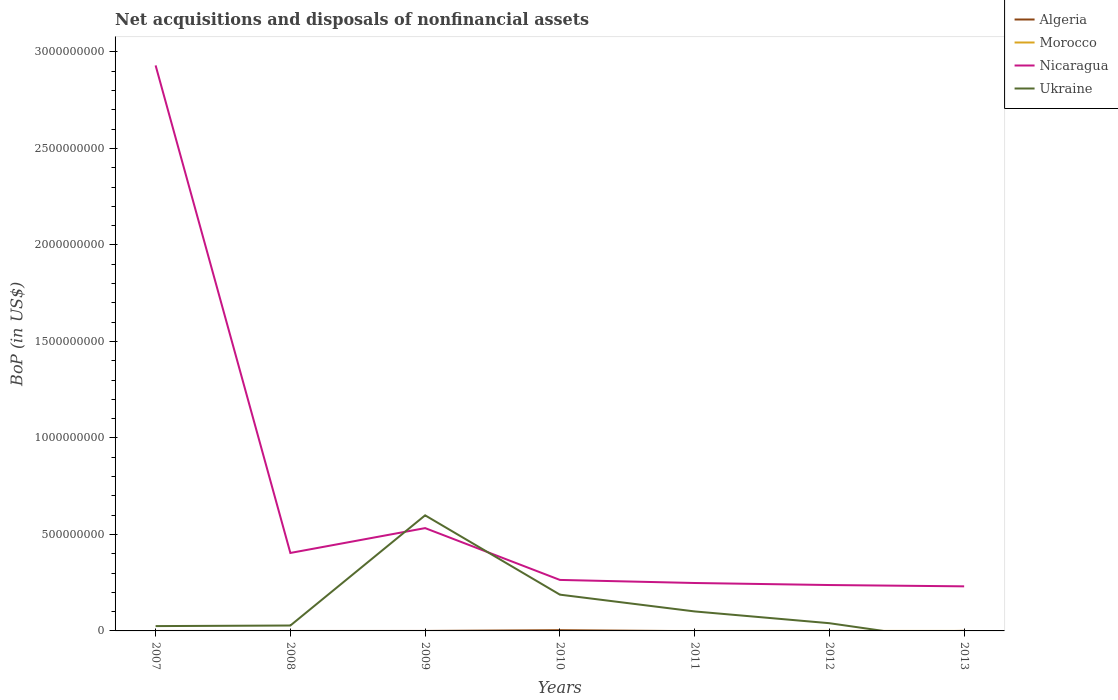Does the line corresponding to Nicaragua intersect with the line corresponding to Algeria?
Offer a very short reply. No. Is the number of lines equal to the number of legend labels?
Offer a terse response. No. What is the total Balance of Payments in Nicaragua in the graph?
Provide a succinct answer. 1.73e+07. What is the difference between the highest and the second highest Balance of Payments in Morocco?
Your response must be concise. 1.28e+05. What is the difference between the highest and the lowest Balance of Payments in Nicaragua?
Your answer should be compact. 1. Is the Balance of Payments in Algeria strictly greater than the Balance of Payments in Morocco over the years?
Your answer should be very brief. No. What is the difference between two consecutive major ticks on the Y-axis?
Your answer should be very brief. 5.00e+08. Does the graph contain any zero values?
Offer a terse response. Yes. Does the graph contain grids?
Your answer should be very brief. No. How are the legend labels stacked?
Your answer should be compact. Vertical. What is the title of the graph?
Provide a short and direct response. Net acquisitions and disposals of nonfinancial assets. Does "Poland" appear as one of the legend labels in the graph?
Your response must be concise. No. What is the label or title of the X-axis?
Ensure brevity in your answer.  Years. What is the label or title of the Y-axis?
Make the answer very short. BoP (in US$). What is the BoP (in US$) of Algeria in 2007?
Your response must be concise. 0. What is the BoP (in US$) in Nicaragua in 2007?
Your answer should be very brief. 2.93e+09. What is the BoP (in US$) in Ukraine in 2007?
Ensure brevity in your answer.  2.50e+07. What is the BoP (in US$) of Morocco in 2008?
Your answer should be very brief. 0. What is the BoP (in US$) in Nicaragua in 2008?
Give a very brief answer. 4.04e+08. What is the BoP (in US$) in Ukraine in 2008?
Provide a succinct answer. 2.80e+07. What is the BoP (in US$) of Algeria in 2009?
Give a very brief answer. 0. What is the BoP (in US$) of Morocco in 2009?
Provide a succinct answer. 0. What is the BoP (in US$) in Nicaragua in 2009?
Make the answer very short. 5.33e+08. What is the BoP (in US$) in Ukraine in 2009?
Offer a very short reply. 5.99e+08. What is the BoP (in US$) in Algeria in 2010?
Ensure brevity in your answer.  3.82e+06. What is the BoP (in US$) of Morocco in 2010?
Ensure brevity in your answer.  0. What is the BoP (in US$) in Nicaragua in 2010?
Your answer should be very brief. 2.64e+08. What is the BoP (in US$) in Ukraine in 2010?
Your answer should be compact. 1.88e+08. What is the BoP (in US$) of Algeria in 2011?
Offer a terse response. 0. What is the BoP (in US$) of Nicaragua in 2011?
Offer a very short reply. 2.48e+08. What is the BoP (in US$) in Ukraine in 2011?
Make the answer very short. 1.01e+08. What is the BoP (in US$) of Algeria in 2012?
Offer a terse response. 0. What is the BoP (in US$) of Morocco in 2012?
Provide a short and direct response. 1.28e+05. What is the BoP (in US$) in Nicaragua in 2012?
Your response must be concise. 2.38e+08. What is the BoP (in US$) of Ukraine in 2012?
Give a very brief answer. 4.00e+07. What is the BoP (in US$) of Algeria in 2013?
Make the answer very short. 2.24e+05. What is the BoP (in US$) of Morocco in 2013?
Offer a terse response. 0. What is the BoP (in US$) of Nicaragua in 2013?
Your answer should be compact. 2.31e+08. What is the BoP (in US$) in Ukraine in 2013?
Provide a succinct answer. 0. Across all years, what is the maximum BoP (in US$) of Algeria?
Your answer should be compact. 3.82e+06. Across all years, what is the maximum BoP (in US$) in Morocco?
Ensure brevity in your answer.  1.28e+05. Across all years, what is the maximum BoP (in US$) in Nicaragua?
Your response must be concise. 2.93e+09. Across all years, what is the maximum BoP (in US$) of Ukraine?
Provide a short and direct response. 5.99e+08. Across all years, what is the minimum BoP (in US$) in Algeria?
Offer a very short reply. 0. Across all years, what is the minimum BoP (in US$) of Nicaragua?
Make the answer very short. 2.31e+08. Across all years, what is the minimum BoP (in US$) in Ukraine?
Provide a short and direct response. 0. What is the total BoP (in US$) of Algeria in the graph?
Provide a short and direct response. 4.05e+06. What is the total BoP (in US$) in Morocco in the graph?
Keep it short and to the point. 1.28e+05. What is the total BoP (in US$) in Nicaragua in the graph?
Your answer should be compact. 4.85e+09. What is the total BoP (in US$) of Ukraine in the graph?
Provide a short and direct response. 9.81e+08. What is the difference between the BoP (in US$) of Nicaragua in 2007 and that in 2008?
Provide a short and direct response. 2.53e+09. What is the difference between the BoP (in US$) in Ukraine in 2007 and that in 2008?
Your answer should be compact. -3.00e+06. What is the difference between the BoP (in US$) in Nicaragua in 2007 and that in 2009?
Offer a terse response. 2.40e+09. What is the difference between the BoP (in US$) in Ukraine in 2007 and that in 2009?
Ensure brevity in your answer.  -5.74e+08. What is the difference between the BoP (in US$) of Nicaragua in 2007 and that in 2010?
Provide a succinct answer. 2.67e+09. What is the difference between the BoP (in US$) of Ukraine in 2007 and that in 2010?
Make the answer very short. -1.63e+08. What is the difference between the BoP (in US$) of Nicaragua in 2007 and that in 2011?
Give a very brief answer. 2.68e+09. What is the difference between the BoP (in US$) of Ukraine in 2007 and that in 2011?
Your answer should be compact. -7.60e+07. What is the difference between the BoP (in US$) in Nicaragua in 2007 and that in 2012?
Your answer should be very brief. 2.69e+09. What is the difference between the BoP (in US$) of Ukraine in 2007 and that in 2012?
Offer a terse response. -1.50e+07. What is the difference between the BoP (in US$) in Nicaragua in 2007 and that in 2013?
Make the answer very short. 2.70e+09. What is the difference between the BoP (in US$) of Nicaragua in 2008 and that in 2009?
Your answer should be very brief. -1.29e+08. What is the difference between the BoP (in US$) of Ukraine in 2008 and that in 2009?
Offer a very short reply. -5.71e+08. What is the difference between the BoP (in US$) of Nicaragua in 2008 and that in 2010?
Make the answer very short. 1.40e+08. What is the difference between the BoP (in US$) in Ukraine in 2008 and that in 2010?
Provide a short and direct response. -1.60e+08. What is the difference between the BoP (in US$) of Nicaragua in 2008 and that in 2011?
Your answer should be very brief. 1.56e+08. What is the difference between the BoP (in US$) of Ukraine in 2008 and that in 2011?
Your response must be concise. -7.30e+07. What is the difference between the BoP (in US$) of Nicaragua in 2008 and that in 2012?
Ensure brevity in your answer.  1.66e+08. What is the difference between the BoP (in US$) in Ukraine in 2008 and that in 2012?
Ensure brevity in your answer.  -1.20e+07. What is the difference between the BoP (in US$) of Nicaragua in 2008 and that in 2013?
Offer a terse response. 1.73e+08. What is the difference between the BoP (in US$) of Nicaragua in 2009 and that in 2010?
Ensure brevity in your answer.  2.68e+08. What is the difference between the BoP (in US$) of Ukraine in 2009 and that in 2010?
Keep it short and to the point. 4.11e+08. What is the difference between the BoP (in US$) of Nicaragua in 2009 and that in 2011?
Provide a short and direct response. 2.84e+08. What is the difference between the BoP (in US$) of Ukraine in 2009 and that in 2011?
Your response must be concise. 4.98e+08. What is the difference between the BoP (in US$) in Nicaragua in 2009 and that in 2012?
Ensure brevity in your answer.  2.95e+08. What is the difference between the BoP (in US$) of Ukraine in 2009 and that in 2012?
Your answer should be very brief. 5.59e+08. What is the difference between the BoP (in US$) of Nicaragua in 2009 and that in 2013?
Offer a terse response. 3.02e+08. What is the difference between the BoP (in US$) of Nicaragua in 2010 and that in 2011?
Ensure brevity in your answer.  1.60e+07. What is the difference between the BoP (in US$) of Ukraine in 2010 and that in 2011?
Keep it short and to the point. 8.70e+07. What is the difference between the BoP (in US$) of Nicaragua in 2010 and that in 2012?
Your response must be concise. 2.65e+07. What is the difference between the BoP (in US$) in Ukraine in 2010 and that in 2012?
Your response must be concise. 1.48e+08. What is the difference between the BoP (in US$) of Algeria in 2010 and that in 2013?
Ensure brevity in your answer.  3.60e+06. What is the difference between the BoP (in US$) in Nicaragua in 2010 and that in 2013?
Your answer should be compact. 3.33e+07. What is the difference between the BoP (in US$) in Nicaragua in 2011 and that in 2012?
Give a very brief answer. 1.05e+07. What is the difference between the BoP (in US$) in Ukraine in 2011 and that in 2012?
Provide a short and direct response. 6.10e+07. What is the difference between the BoP (in US$) of Nicaragua in 2011 and that in 2013?
Your answer should be very brief. 1.73e+07. What is the difference between the BoP (in US$) in Nicaragua in 2012 and that in 2013?
Keep it short and to the point. 6.80e+06. What is the difference between the BoP (in US$) of Nicaragua in 2007 and the BoP (in US$) of Ukraine in 2008?
Your answer should be very brief. 2.90e+09. What is the difference between the BoP (in US$) in Nicaragua in 2007 and the BoP (in US$) in Ukraine in 2009?
Your answer should be very brief. 2.33e+09. What is the difference between the BoP (in US$) of Nicaragua in 2007 and the BoP (in US$) of Ukraine in 2010?
Offer a terse response. 2.74e+09. What is the difference between the BoP (in US$) of Nicaragua in 2007 and the BoP (in US$) of Ukraine in 2011?
Offer a terse response. 2.83e+09. What is the difference between the BoP (in US$) of Nicaragua in 2007 and the BoP (in US$) of Ukraine in 2012?
Provide a succinct answer. 2.89e+09. What is the difference between the BoP (in US$) in Nicaragua in 2008 and the BoP (in US$) in Ukraine in 2009?
Offer a very short reply. -1.95e+08. What is the difference between the BoP (in US$) of Nicaragua in 2008 and the BoP (in US$) of Ukraine in 2010?
Ensure brevity in your answer.  2.16e+08. What is the difference between the BoP (in US$) of Nicaragua in 2008 and the BoP (in US$) of Ukraine in 2011?
Ensure brevity in your answer.  3.03e+08. What is the difference between the BoP (in US$) of Nicaragua in 2008 and the BoP (in US$) of Ukraine in 2012?
Make the answer very short. 3.64e+08. What is the difference between the BoP (in US$) of Nicaragua in 2009 and the BoP (in US$) of Ukraine in 2010?
Your response must be concise. 3.45e+08. What is the difference between the BoP (in US$) in Nicaragua in 2009 and the BoP (in US$) in Ukraine in 2011?
Keep it short and to the point. 4.32e+08. What is the difference between the BoP (in US$) in Nicaragua in 2009 and the BoP (in US$) in Ukraine in 2012?
Give a very brief answer. 4.93e+08. What is the difference between the BoP (in US$) in Algeria in 2010 and the BoP (in US$) in Nicaragua in 2011?
Make the answer very short. -2.44e+08. What is the difference between the BoP (in US$) in Algeria in 2010 and the BoP (in US$) in Ukraine in 2011?
Offer a very short reply. -9.72e+07. What is the difference between the BoP (in US$) in Nicaragua in 2010 and the BoP (in US$) in Ukraine in 2011?
Give a very brief answer. 1.63e+08. What is the difference between the BoP (in US$) of Algeria in 2010 and the BoP (in US$) of Morocco in 2012?
Give a very brief answer. 3.70e+06. What is the difference between the BoP (in US$) in Algeria in 2010 and the BoP (in US$) in Nicaragua in 2012?
Ensure brevity in your answer.  -2.34e+08. What is the difference between the BoP (in US$) in Algeria in 2010 and the BoP (in US$) in Ukraine in 2012?
Your response must be concise. -3.62e+07. What is the difference between the BoP (in US$) in Nicaragua in 2010 and the BoP (in US$) in Ukraine in 2012?
Make the answer very short. 2.24e+08. What is the difference between the BoP (in US$) of Algeria in 2010 and the BoP (in US$) of Nicaragua in 2013?
Keep it short and to the point. -2.27e+08. What is the difference between the BoP (in US$) of Nicaragua in 2011 and the BoP (in US$) of Ukraine in 2012?
Provide a short and direct response. 2.08e+08. What is the difference between the BoP (in US$) of Morocco in 2012 and the BoP (in US$) of Nicaragua in 2013?
Offer a terse response. -2.31e+08. What is the average BoP (in US$) in Algeria per year?
Ensure brevity in your answer.  5.78e+05. What is the average BoP (in US$) of Morocco per year?
Provide a succinct answer. 1.83e+04. What is the average BoP (in US$) in Nicaragua per year?
Ensure brevity in your answer.  6.93e+08. What is the average BoP (in US$) in Ukraine per year?
Offer a very short reply. 1.40e+08. In the year 2007, what is the difference between the BoP (in US$) of Nicaragua and BoP (in US$) of Ukraine?
Provide a succinct answer. 2.91e+09. In the year 2008, what is the difference between the BoP (in US$) of Nicaragua and BoP (in US$) of Ukraine?
Make the answer very short. 3.76e+08. In the year 2009, what is the difference between the BoP (in US$) of Nicaragua and BoP (in US$) of Ukraine?
Keep it short and to the point. -6.62e+07. In the year 2010, what is the difference between the BoP (in US$) of Algeria and BoP (in US$) of Nicaragua?
Give a very brief answer. -2.60e+08. In the year 2010, what is the difference between the BoP (in US$) of Algeria and BoP (in US$) of Ukraine?
Your response must be concise. -1.84e+08. In the year 2010, what is the difference between the BoP (in US$) of Nicaragua and BoP (in US$) of Ukraine?
Offer a terse response. 7.63e+07. In the year 2011, what is the difference between the BoP (in US$) in Nicaragua and BoP (in US$) in Ukraine?
Offer a terse response. 1.47e+08. In the year 2012, what is the difference between the BoP (in US$) in Morocco and BoP (in US$) in Nicaragua?
Provide a short and direct response. -2.38e+08. In the year 2012, what is the difference between the BoP (in US$) in Morocco and BoP (in US$) in Ukraine?
Offer a terse response. -3.99e+07. In the year 2012, what is the difference between the BoP (in US$) of Nicaragua and BoP (in US$) of Ukraine?
Your answer should be very brief. 1.98e+08. In the year 2013, what is the difference between the BoP (in US$) of Algeria and BoP (in US$) of Nicaragua?
Offer a terse response. -2.31e+08. What is the ratio of the BoP (in US$) in Nicaragua in 2007 to that in 2008?
Make the answer very short. 7.25. What is the ratio of the BoP (in US$) in Ukraine in 2007 to that in 2008?
Your response must be concise. 0.89. What is the ratio of the BoP (in US$) of Nicaragua in 2007 to that in 2009?
Offer a very short reply. 5.5. What is the ratio of the BoP (in US$) in Ukraine in 2007 to that in 2009?
Offer a terse response. 0.04. What is the ratio of the BoP (in US$) of Nicaragua in 2007 to that in 2010?
Provide a short and direct response. 11.09. What is the ratio of the BoP (in US$) of Ukraine in 2007 to that in 2010?
Your answer should be very brief. 0.13. What is the ratio of the BoP (in US$) in Nicaragua in 2007 to that in 2011?
Offer a very short reply. 11.8. What is the ratio of the BoP (in US$) of Ukraine in 2007 to that in 2011?
Provide a succinct answer. 0.25. What is the ratio of the BoP (in US$) of Nicaragua in 2007 to that in 2012?
Your answer should be compact. 12.32. What is the ratio of the BoP (in US$) of Nicaragua in 2007 to that in 2013?
Offer a very short reply. 12.69. What is the ratio of the BoP (in US$) in Nicaragua in 2008 to that in 2009?
Make the answer very short. 0.76. What is the ratio of the BoP (in US$) of Ukraine in 2008 to that in 2009?
Offer a terse response. 0.05. What is the ratio of the BoP (in US$) in Nicaragua in 2008 to that in 2010?
Provide a succinct answer. 1.53. What is the ratio of the BoP (in US$) in Ukraine in 2008 to that in 2010?
Your answer should be very brief. 0.15. What is the ratio of the BoP (in US$) in Nicaragua in 2008 to that in 2011?
Your answer should be compact. 1.63. What is the ratio of the BoP (in US$) in Ukraine in 2008 to that in 2011?
Provide a short and direct response. 0.28. What is the ratio of the BoP (in US$) of Nicaragua in 2008 to that in 2012?
Your answer should be compact. 1.7. What is the ratio of the BoP (in US$) of Ukraine in 2008 to that in 2012?
Your response must be concise. 0.7. What is the ratio of the BoP (in US$) of Nicaragua in 2008 to that in 2013?
Keep it short and to the point. 1.75. What is the ratio of the BoP (in US$) in Nicaragua in 2009 to that in 2010?
Offer a terse response. 2.02. What is the ratio of the BoP (in US$) in Ukraine in 2009 to that in 2010?
Provide a short and direct response. 3.19. What is the ratio of the BoP (in US$) of Nicaragua in 2009 to that in 2011?
Your answer should be very brief. 2.15. What is the ratio of the BoP (in US$) in Ukraine in 2009 to that in 2011?
Ensure brevity in your answer.  5.93. What is the ratio of the BoP (in US$) in Nicaragua in 2009 to that in 2012?
Ensure brevity in your answer.  2.24. What is the ratio of the BoP (in US$) in Ukraine in 2009 to that in 2012?
Your answer should be very brief. 14.97. What is the ratio of the BoP (in US$) of Nicaragua in 2009 to that in 2013?
Give a very brief answer. 2.31. What is the ratio of the BoP (in US$) of Nicaragua in 2010 to that in 2011?
Give a very brief answer. 1.06. What is the ratio of the BoP (in US$) of Ukraine in 2010 to that in 2011?
Provide a short and direct response. 1.86. What is the ratio of the BoP (in US$) of Nicaragua in 2010 to that in 2012?
Your answer should be very brief. 1.11. What is the ratio of the BoP (in US$) in Ukraine in 2010 to that in 2012?
Give a very brief answer. 4.7. What is the ratio of the BoP (in US$) of Algeria in 2010 to that in 2013?
Your answer should be compact. 17.08. What is the ratio of the BoP (in US$) of Nicaragua in 2010 to that in 2013?
Offer a very short reply. 1.14. What is the ratio of the BoP (in US$) of Nicaragua in 2011 to that in 2012?
Your response must be concise. 1.04. What is the ratio of the BoP (in US$) in Ukraine in 2011 to that in 2012?
Your answer should be very brief. 2.52. What is the ratio of the BoP (in US$) of Nicaragua in 2011 to that in 2013?
Your answer should be compact. 1.07. What is the ratio of the BoP (in US$) of Nicaragua in 2012 to that in 2013?
Provide a short and direct response. 1.03. What is the difference between the highest and the second highest BoP (in US$) in Nicaragua?
Ensure brevity in your answer.  2.40e+09. What is the difference between the highest and the second highest BoP (in US$) of Ukraine?
Keep it short and to the point. 4.11e+08. What is the difference between the highest and the lowest BoP (in US$) in Algeria?
Offer a very short reply. 3.82e+06. What is the difference between the highest and the lowest BoP (in US$) in Morocco?
Offer a terse response. 1.28e+05. What is the difference between the highest and the lowest BoP (in US$) in Nicaragua?
Your answer should be very brief. 2.70e+09. What is the difference between the highest and the lowest BoP (in US$) in Ukraine?
Offer a very short reply. 5.99e+08. 